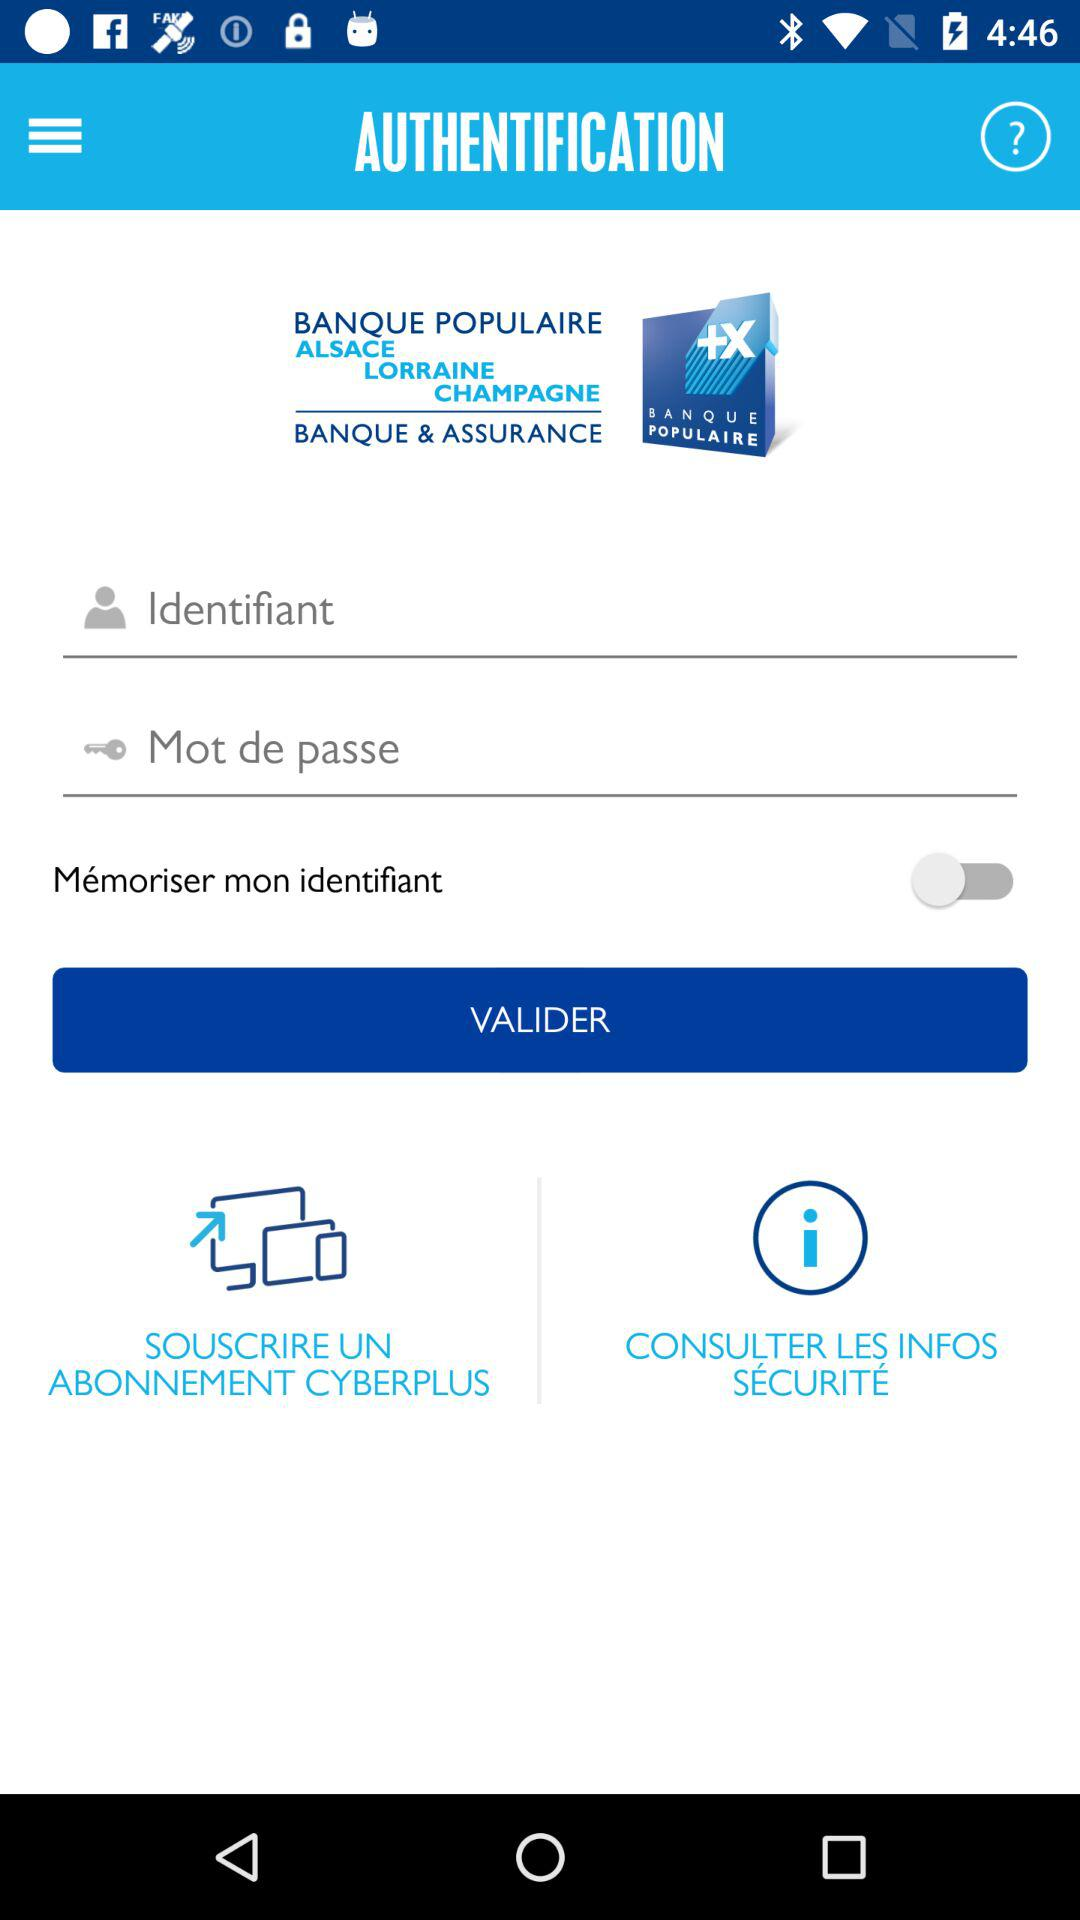How many text fields are there in the login screen?
Answer the question using a single word or phrase. 2 